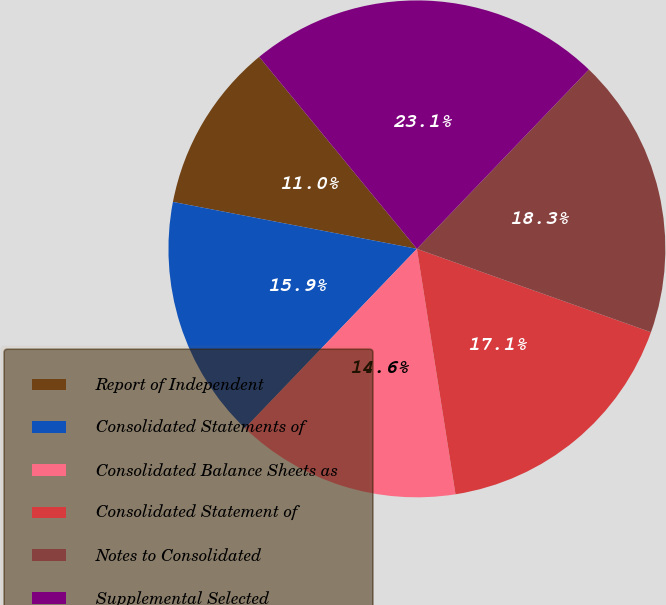<chart> <loc_0><loc_0><loc_500><loc_500><pie_chart><fcel>Report of Independent<fcel>Consolidated Statements of<fcel>Consolidated Balance Sheets as<fcel>Consolidated Statement of<fcel>Notes to Consolidated<fcel>Supplemental Selected<nl><fcel>11.03%<fcel>15.86%<fcel>14.65%<fcel>17.07%<fcel>18.28%<fcel>23.11%<nl></chart> 